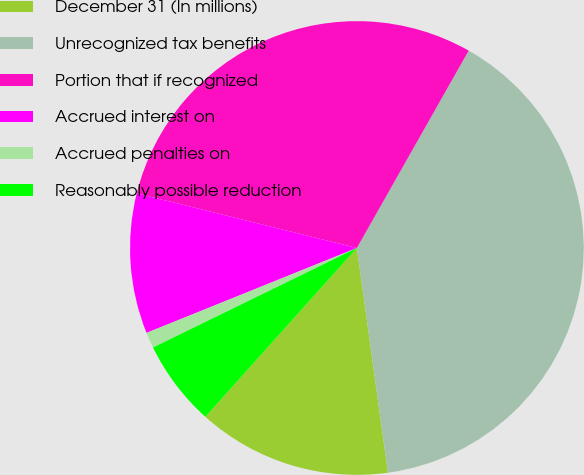Convert chart to OTSL. <chart><loc_0><loc_0><loc_500><loc_500><pie_chart><fcel>December 31 (In millions)<fcel>Unrecognized tax benefits<fcel>Portion that if recognized<fcel>Accrued interest on<fcel>Accrued penalties on<fcel>Reasonably possible reduction<nl><fcel>13.83%<fcel>39.61%<fcel>29.33%<fcel>9.98%<fcel>1.12%<fcel>6.13%<nl></chart> 